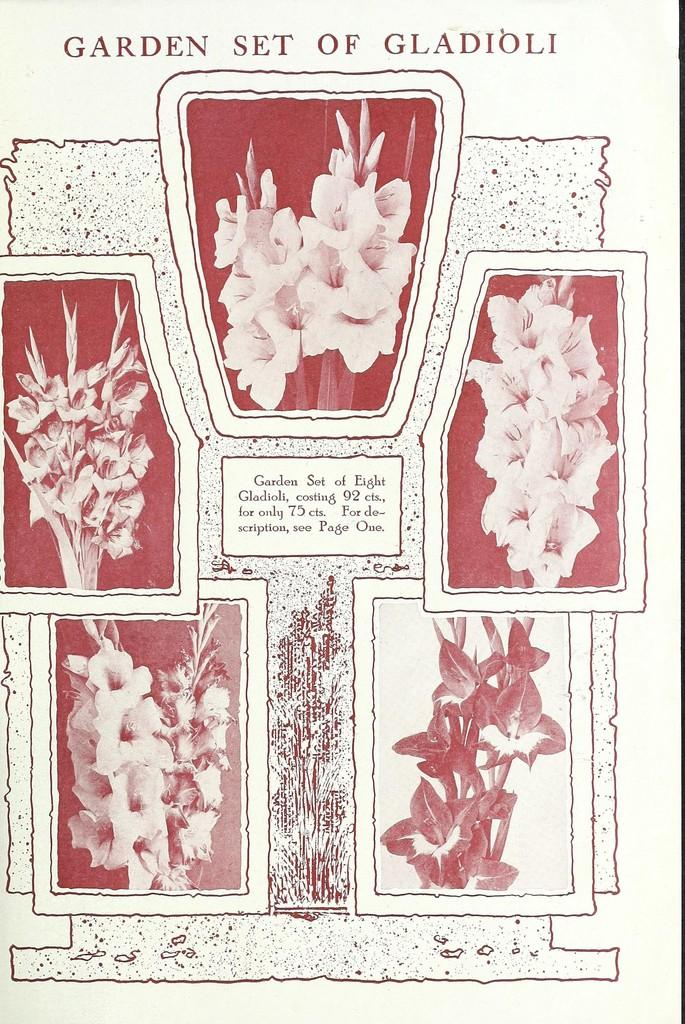What is the main subject of the paper in the image? The paper contains pictures of flowers. Is there any text on the paper? Yes, there is text on the paper. What type of pipe is visible in the image? There is no pipe present in the image. What is the income of the person who created the paper? The income of the person who created the paper is not mentioned or visible in the image. 